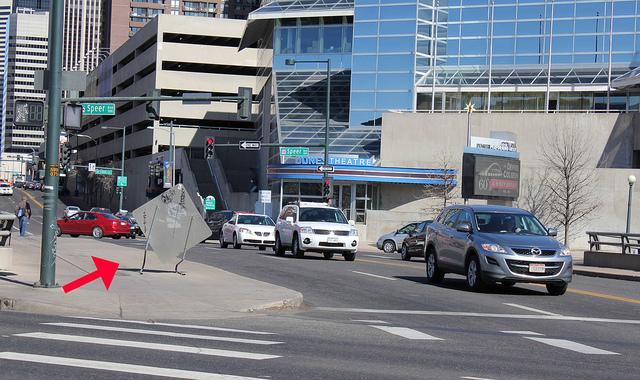What boulevard is the Jones Theater on?

Choices:
A) speer
B) 12th
C) curtis
D) spire speer 